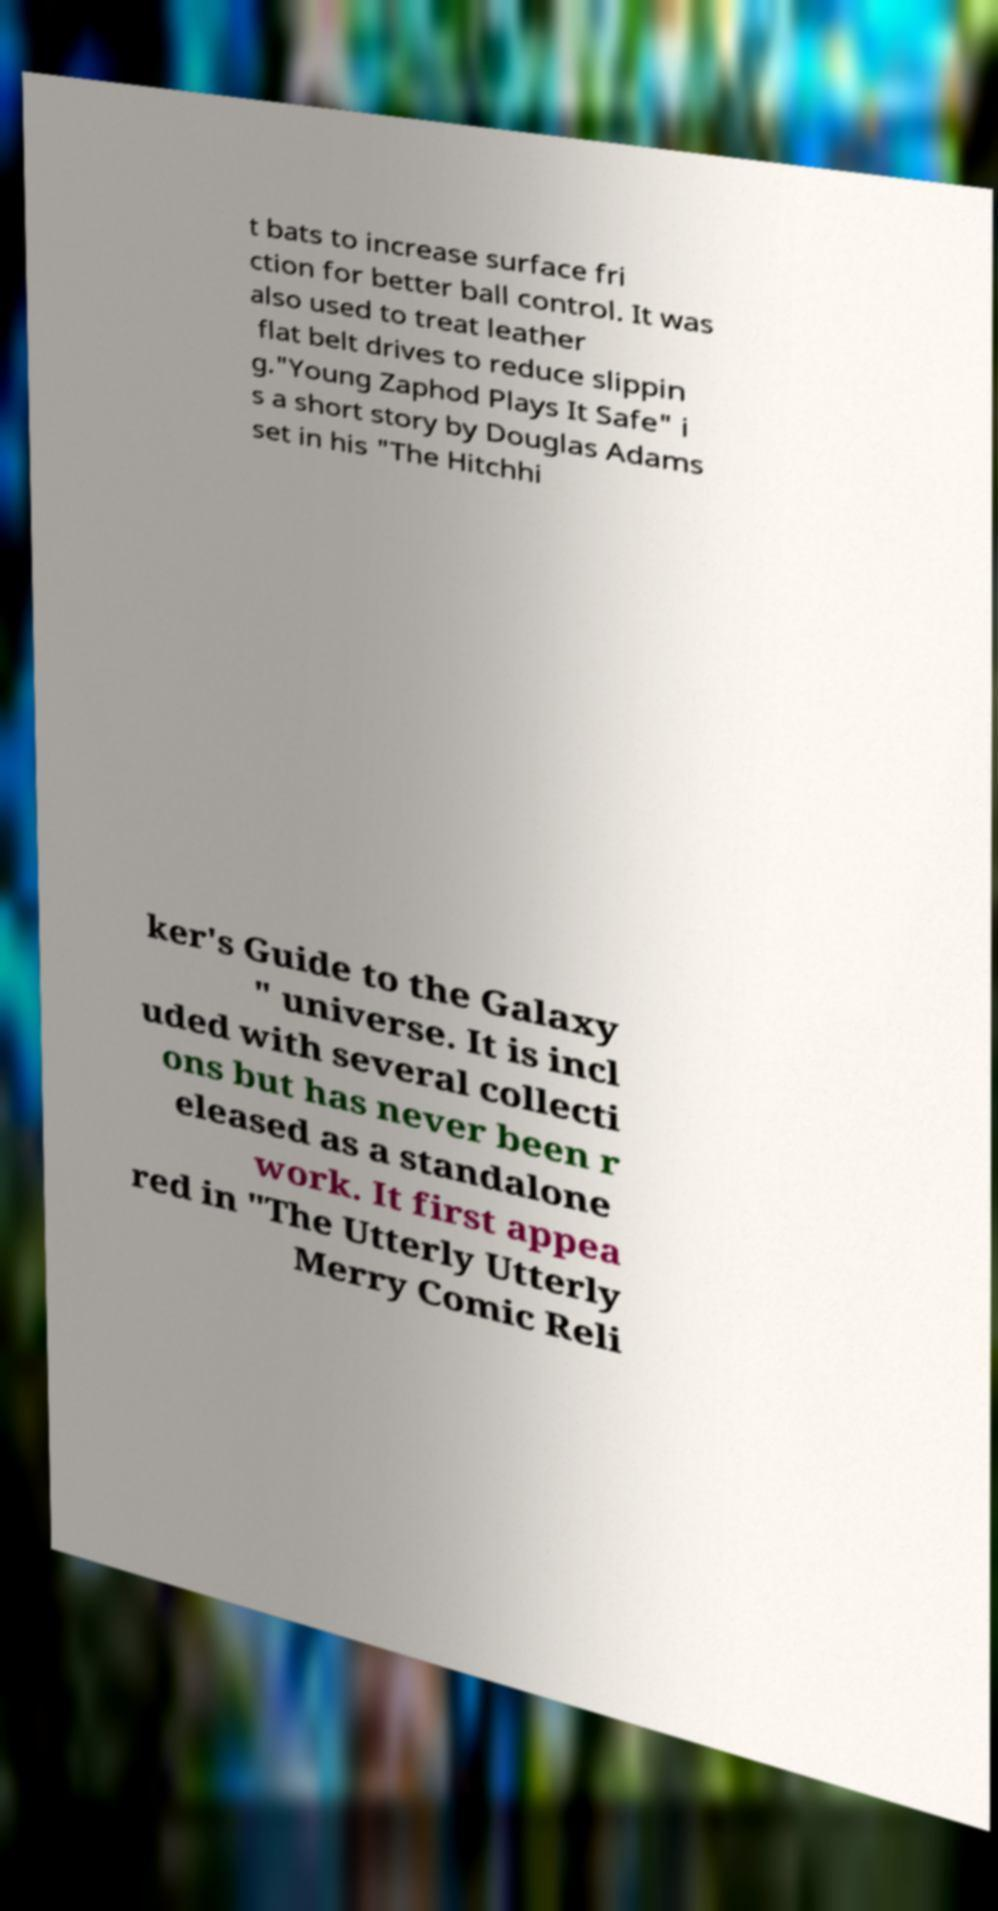There's text embedded in this image that I need extracted. Can you transcribe it verbatim? t bats to increase surface fri ction for better ball control. It was also used to treat leather flat belt drives to reduce slippin g."Young Zaphod Plays It Safe" i s a short story by Douglas Adams set in his "The Hitchhi ker's Guide to the Galaxy " universe. It is incl uded with several collecti ons but has never been r eleased as a standalone work. It first appea red in "The Utterly Utterly Merry Comic Reli 